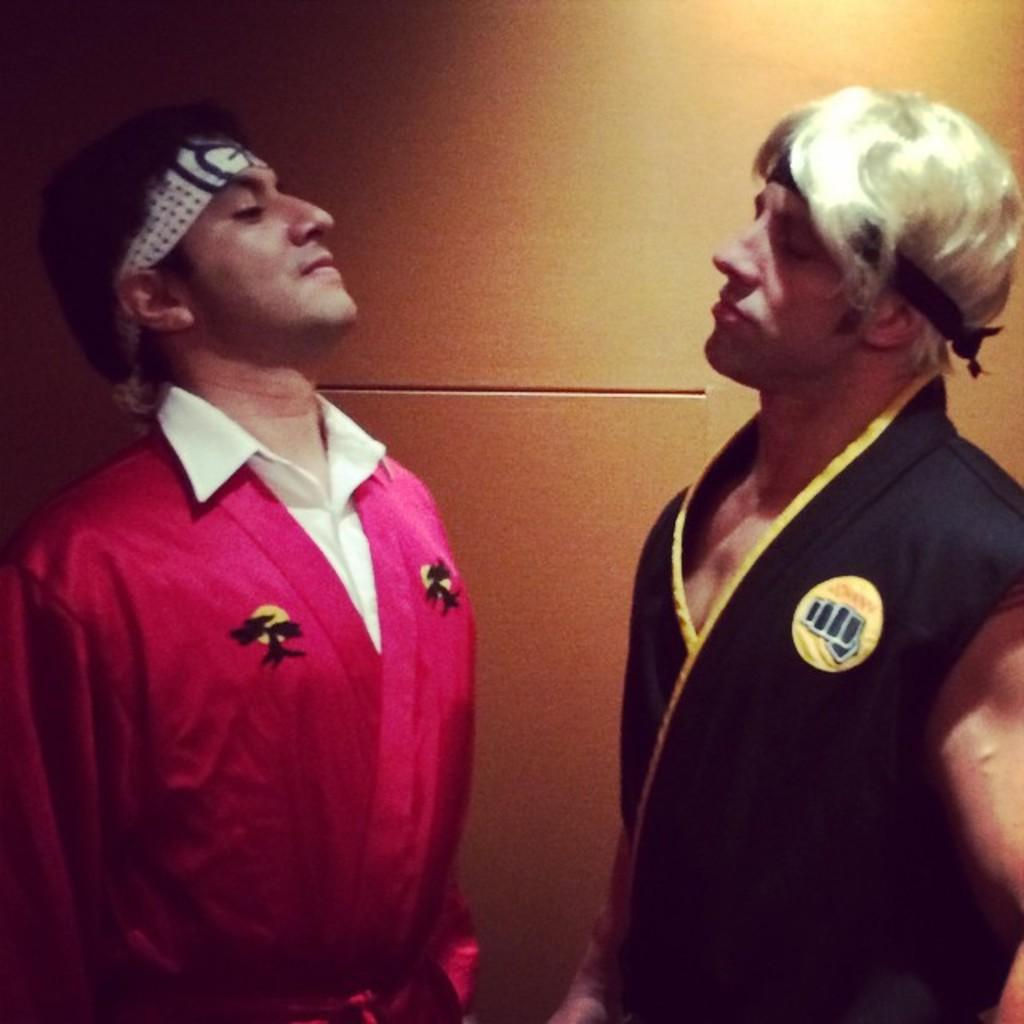How many people are present in the image? There are two persons standing in the image. Can you describe the background of the image? There is a well in the background of the image. What rule is being enforced by the persons in the image? There is no indication of any rule being enforced in the image. What songs are being sung by the persons in the image? There is no indication of any songs being sung in the image. Can you see any visible teeth of the persons in the image? The image does not provide a clear view of the persons' teeth. 